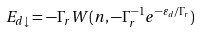<formula> <loc_0><loc_0><loc_500><loc_500>E _ { d \downarrow } = - \Gamma _ { r } W ( n , - { \Gamma _ { r } ^ { - 1 } } { e ^ { - { \varepsilon _ { d } } / { \Gamma _ { r } } } } )</formula> 